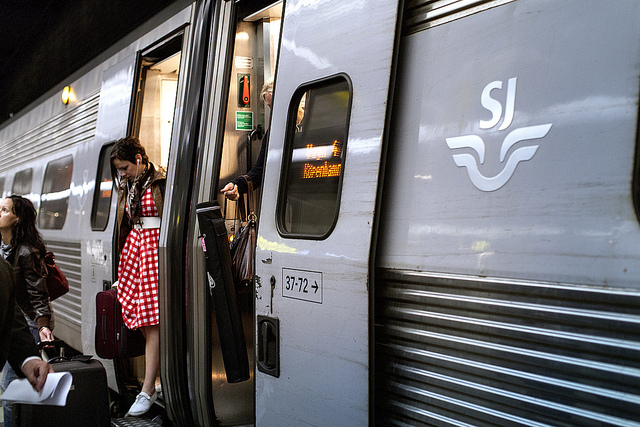Read and extract the text from this image. SJ 37.-72 